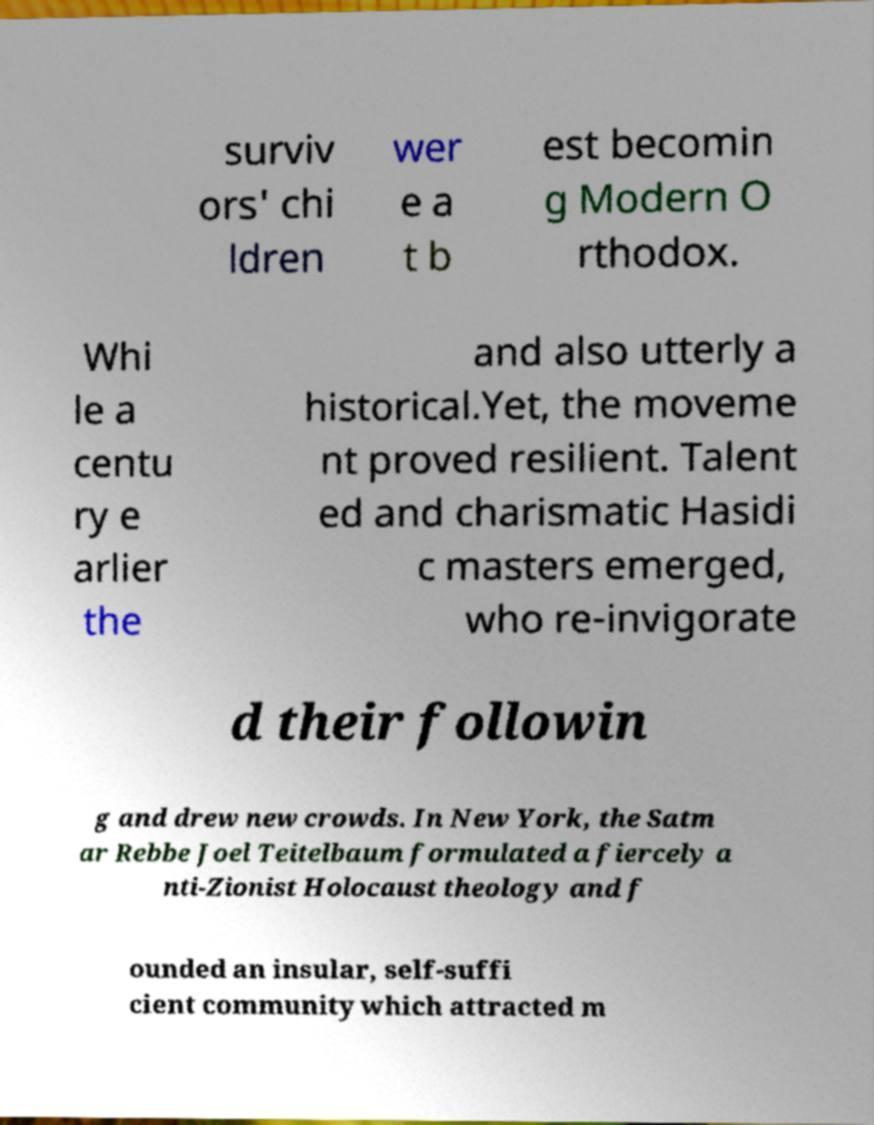Can you read and provide the text displayed in the image?This photo seems to have some interesting text. Can you extract and type it out for me? surviv ors' chi ldren wer e a t b est becomin g Modern O rthodox. Whi le a centu ry e arlier the and also utterly a historical.Yet, the moveme nt proved resilient. Talent ed and charismatic Hasidi c masters emerged, who re-invigorate d their followin g and drew new crowds. In New York, the Satm ar Rebbe Joel Teitelbaum formulated a fiercely a nti-Zionist Holocaust theology and f ounded an insular, self-suffi cient community which attracted m 